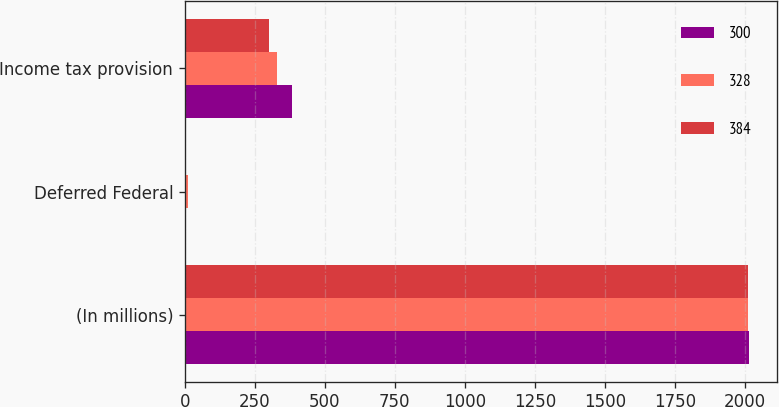Convert chart. <chart><loc_0><loc_0><loc_500><loc_500><stacked_bar_chart><ecel><fcel>(In millions)<fcel>Deferred Federal<fcel>Income tax provision<nl><fcel>300<fcel>2014<fcel>4<fcel>384<nl><fcel>328<fcel>2013<fcel>12<fcel>328<nl><fcel>384<fcel>2012<fcel>3<fcel>300<nl></chart> 